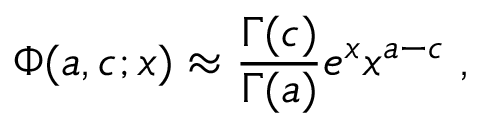Convert formula to latex. <formula><loc_0><loc_0><loc_500><loc_500>\Phi ( a , c ; x ) \approx { \frac { \Gamma ( c ) } { \Gamma ( a ) } } e ^ { x } x ^ { a - c } \, , \,</formula> 